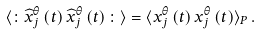<formula> <loc_0><loc_0><loc_500><loc_500>\langle \colon \widehat { x } _ { j } ^ { \theta } \left ( t \right ) \widehat { x } _ { j } ^ { \theta } \left ( t \right ) \colon \rangle = \langle { x } _ { j } ^ { \theta } \left ( t \right ) { x } _ { j } ^ { \theta } \left ( t \right ) \rangle _ { P } \, .</formula> 